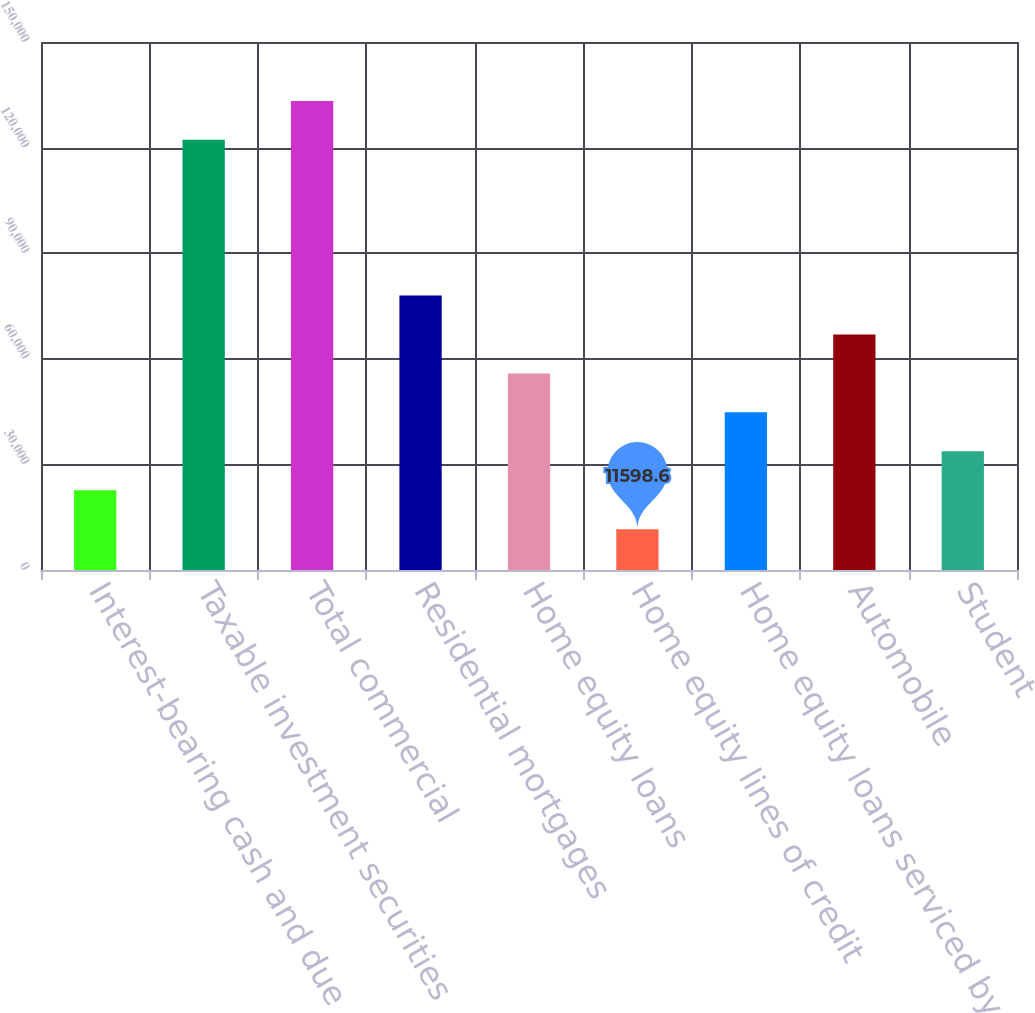Convert chart to OTSL. <chart><loc_0><loc_0><loc_500><loc_500><bar_chart><fcel>Interest-bearing cash and due<fcel>Taxable investment securities<fcel>Total commercial<fcel>Residential mortgages<fcel>Home equity loans<fcel>Home equity lines of credit<fcel>Home equity loans serviced by<fcel>Automobile<fcel>Student<nl><fcel>22659.2<fcel>122205<fcel>133265<fcel>77962.2<fcel>55841<fcel>11598.6<fcel>44780.4<fcel>66901.6<fcel>33719.8<nl></chart> 